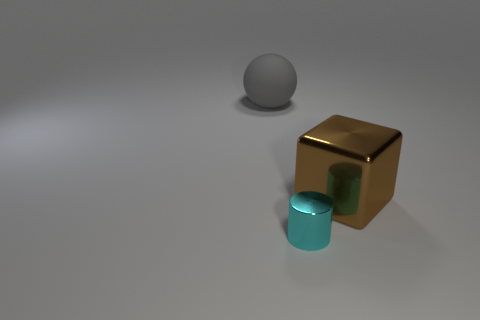Add 3 green rubber cylinders. How many objects exist? 6 Subtract all spheres. How many objects are left? 2 Subtract all purple cylinders. Subtract all yellow balls. How many cylinders are left? 1 Subtract all yellow cylinders. How many cyan cubes are left? 0 Subtract all matte spheres. Subtract all brown things. How many objects are left? 1 Add 1 tiny cylinders. How many tiny cylinders are left? 2 Add 1 cyan objects. How many cyan objects exist? 2 Subtract 0 gray blocks. How many objects are left? 3 